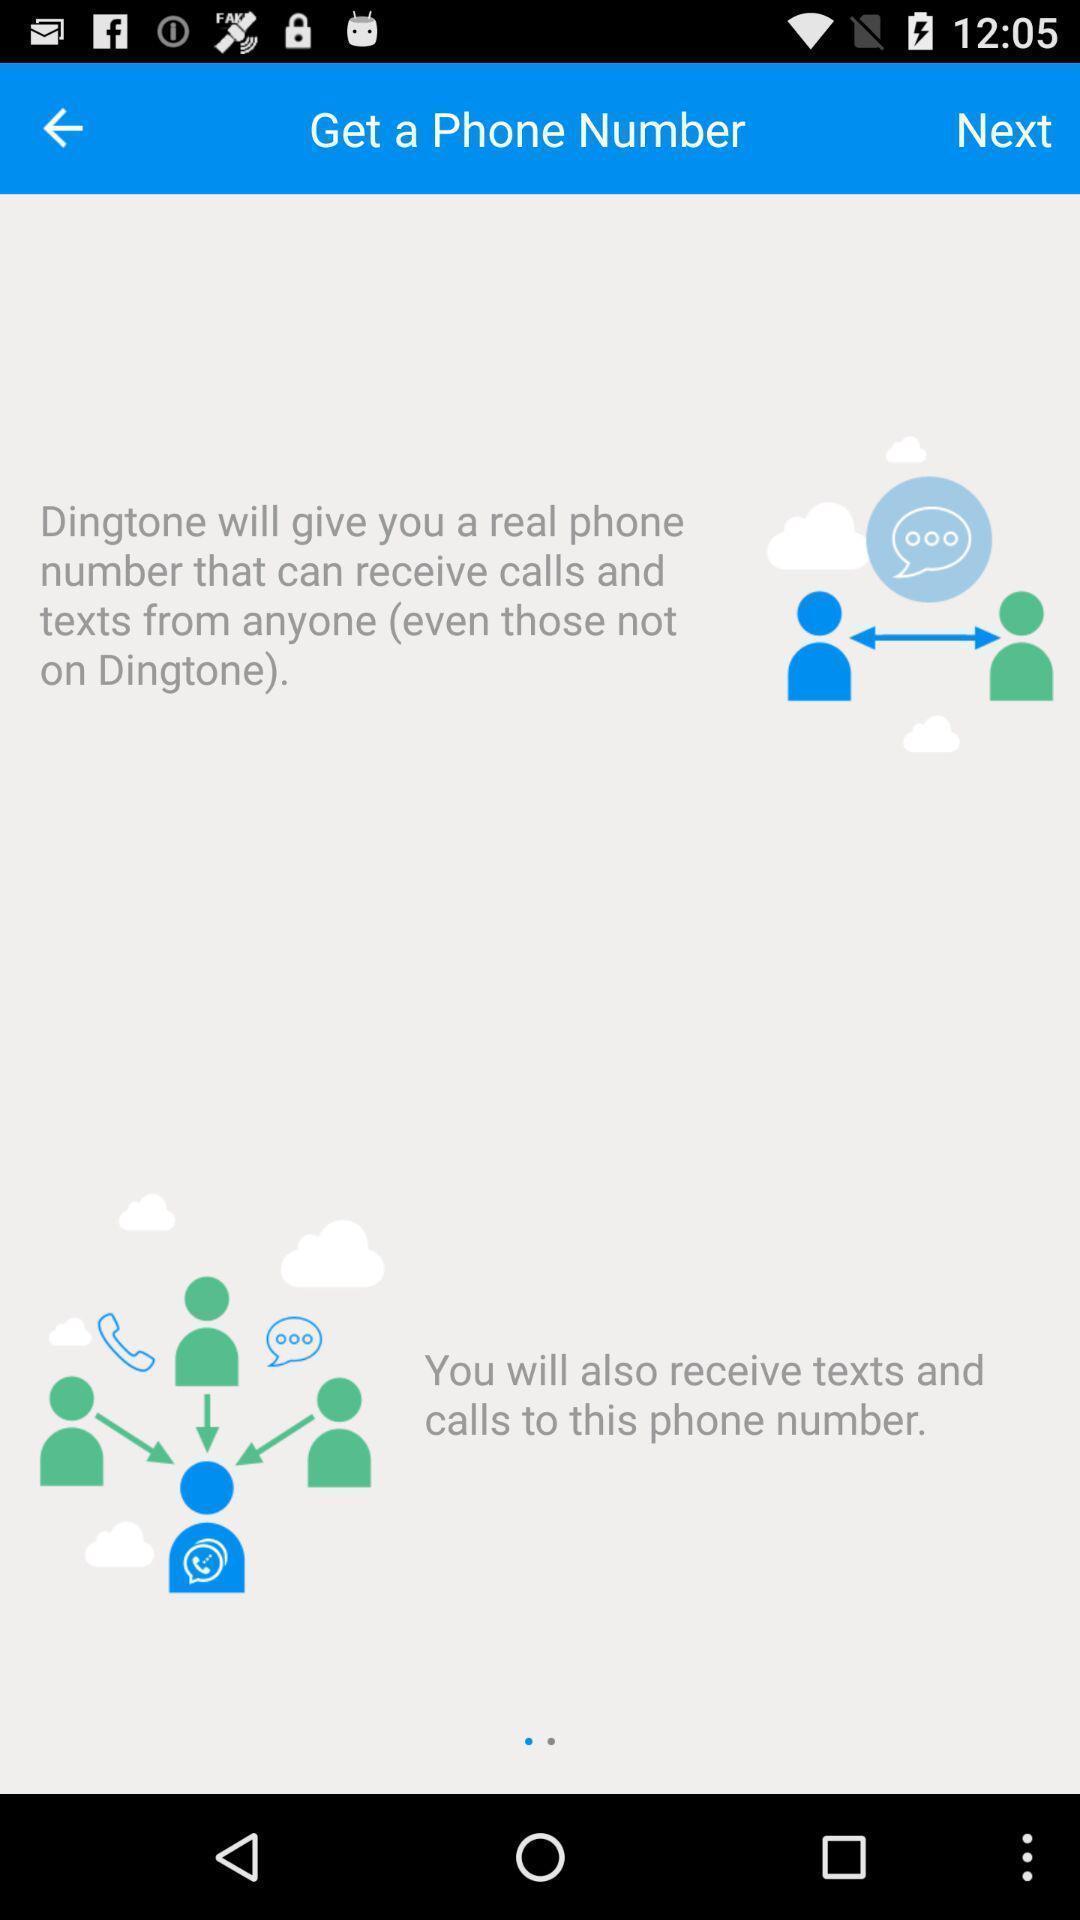Describe the content in this image. Screen displaying the instructions to get a phone number. 